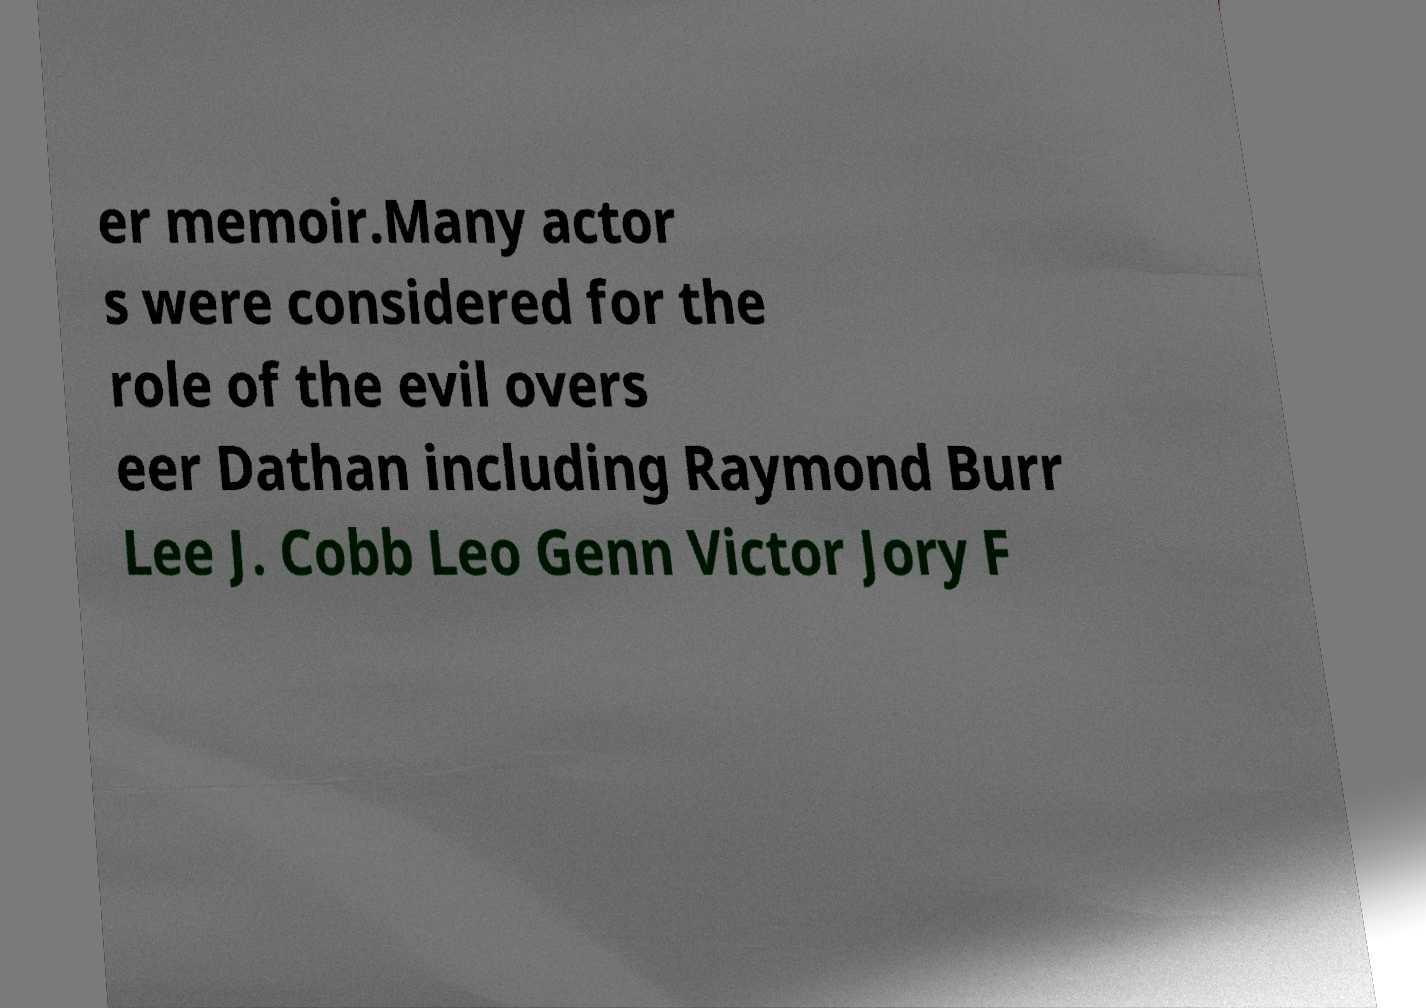There's text embedded in this image that I need extracted. Can you transcribe it verbatim? er memoir.Many actor s were considered for the role of the evil overs eer Dathan including Raymond Burr Lee J. Cobb Leo Genn Victor Jory F 